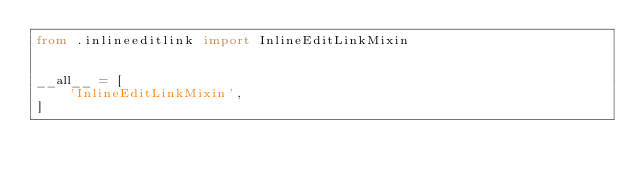<code> <loc_0><loc_0><loc_500><loc_500><_Python_>from .inlineeditlink import InlineEditLinkMixin


__all__ = [
    'InlineEditLinkMixin',
]
</code> 